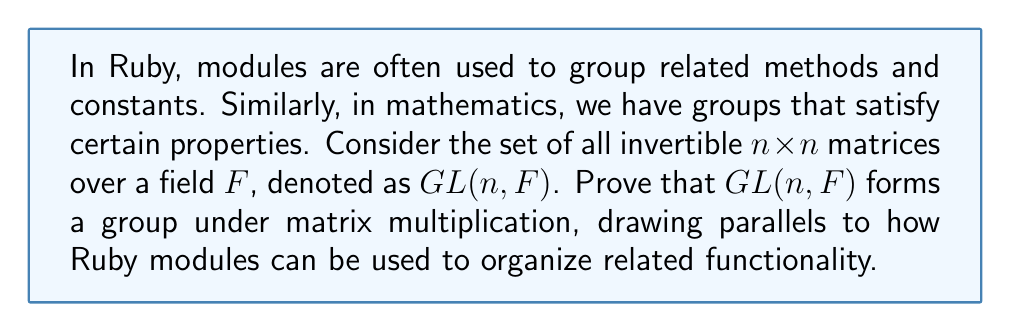What is the answer to this math problem? To prove that $GL(n, F)$ forms a group under matrix multiplication, we need to show that it satisfies the four group axioms. Let's go through each axiom step by step, relating it to concepts in Ruby where applicable:

1. Closure:
For any $A, B \in GL(n, F)$, we need to show that $AB \in GL(n, F)$.
- $A$ and $B$ are invertible, so $\det(A) \neq 0$ and $\det(B) \neq 0$
- $\det(AB) = \det(A) \cdot \det(B) \neq 0$
- Therefore, $AB$ is invertible and belongs to $GL(n, F)$

This is similar to how methods defined in a Ruby module can be called on any object that includes that module.

2. Associativity:
For any $A, B, C \in GL(n, F)$, we need to show that $(AB)C = A(BC)$.
- This holds for all matrices, not just invertible ones
- Matrix multiplication is always associative

In Ruby, method chaining follows the same principle of associativity.

3. Identity element:
We need to show that there exists an identity element $I \in GL(n, F)$ such that $AI = IA = A$ for all $A \in GL(n, F)$.
- The identity matrix $I$ serves this purpose
- $I$ is invertible (its determinant is 1)
- $AI = IA = A$ for all matrices $A$

This is analogous to how Ruby's `Object` class serves as a root for all classes, providing common functionality.

4. Inverse element:
For each $A \in GL(n, F)$, we need to show that there exists an inverse $A^{-1} \in GL(n, F)$ such that $AA^{-1} = A^{-1}A = I$.
- By definition, every matrix in $GL(n, F)$ is invertible
- The inverse of an invertible matrix is also invertible
- Therefore, $A^{-1} \in GL(n, F)$ for all $A \in GL(n, F)$

In Ruby, this could be compared to how modules can define methods that undo the effects of other methods, creating a form of invertibility in functionality.

Since all four group axioms are satisfied, $GL(n, F)$ forms a group under matrix multiplication.
Answer: $GL(n, F)$ forms a group under matrix multiplication because it satisfies all four group axioms: closure, associativity, identity element, and inverse element. 